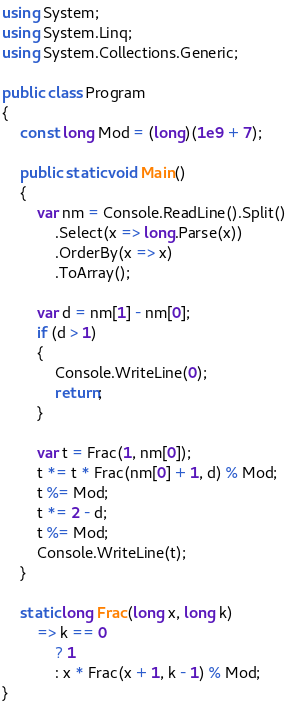<code> <loc_0><loc_0><loc_500><loc_500><_C#_>using System;
using System.Linq;
using System.Collections.Generic;

public class Program
{
    const long Mod = (long)(1e9 + 7);
    
    public static void Main()
    {
        var nm = Console.ReadLine().Split()
            .Select(x => long.Parse(x))
            .OrderBy(x => x)
            .ToArray();

        var d = nm[1] - nm[0];
        if (d > 1)
        {
            Console.WriteLine(0);
            return;
        }

        var t = Frac(1, nm[0]);
        t *= t * Frac(nm[0] + 1, d) % Mod;
        t %= Mod;
        t *= 2 - d;
        t %= Mod;
        Console.WriteLine(t);
    }

    static long Frac(long x, long k)
        => k == 0
            ? 1
            : x * Frac(x + 1, k - 1) % Mod;
}
</code> 